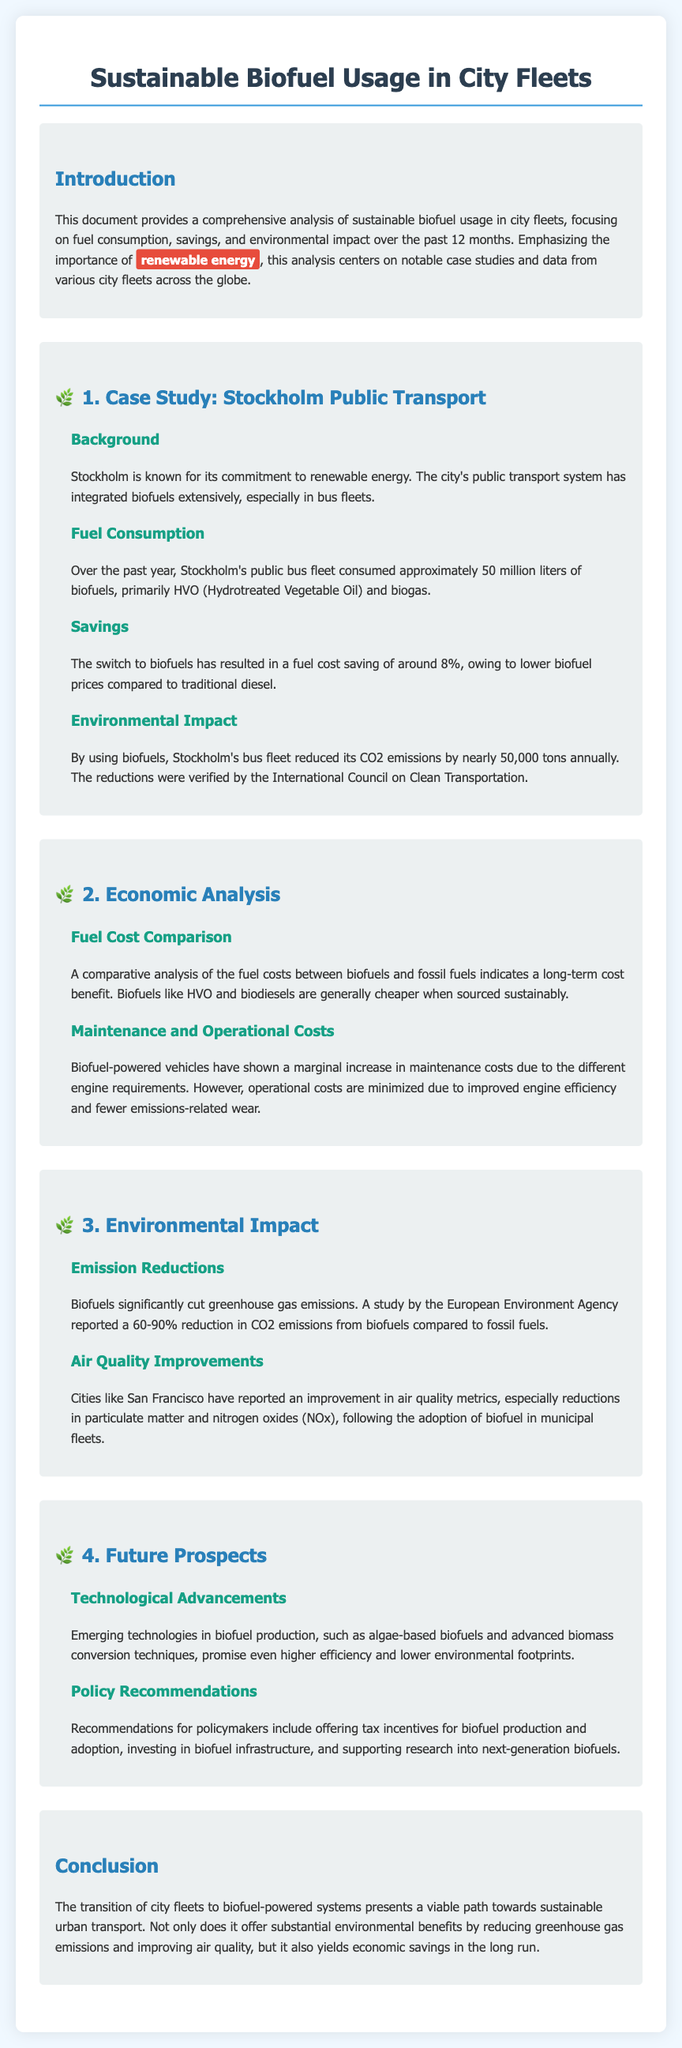What is the primary biofuel used in Stockholm's public transport? The document states that Stockholm's public bus fleet primarily used HVO (Hydrotreated Vegetable Oil) and biogas over the past year.
Answer: HVO and biogas How many liters of biofuels did Stockholm's public bus fleet consume? The document mentions that approximately 50 million liters of biofuels were consumed by Stockholm's bus fleet.
Answer: 50 million liters What is the percentage fuel cost saving from switching to biofuels in Stockholm? The document indicates that the switch to biofuels has resulted in a fuel cost saving of around 8%.
Answer: 8% What percentage reduction in CO2 emissions was reported from biofuels compared to fossil fuels? The document cites a study reporting a 60-90% reduction in CO2 emissions from biofuels compared to fossil fuels.
Answer: 60-90% Which city reported improvement in air quality metrics after adopting biofuels? The document specifies that San Francisco reported improvements in air quality metrics following the adoption of biofuel in municipal fleets.
Answer: San Francisco What future biofuel technology is mentioned for higher efficiency? The document discusses emerging technologies in biofuel production, specifically mentioning algae-based biofuels.
Answer: Algae-based biofuels What is one recommended policy for promoting biofuels? The document suggests offering tax incentives for biofuel production and adoption as a policy recommendation.
Answer: Tax incentives 